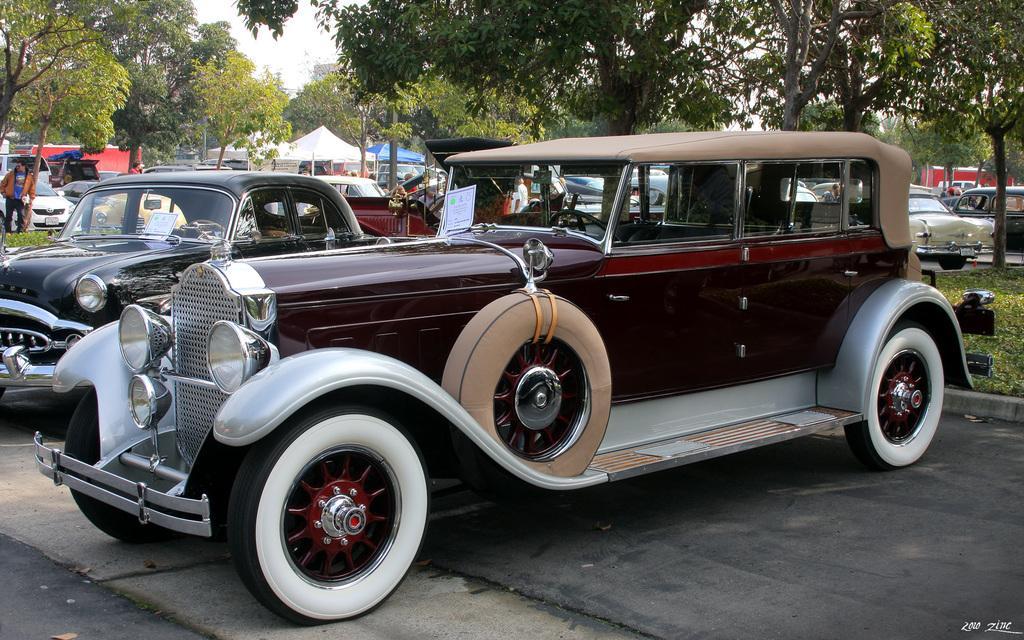Can you describe this image briefly? In the picture I can see vehicles on the ground. In the background I can see trees, the grass, people, the sky, fence and some other objects. 